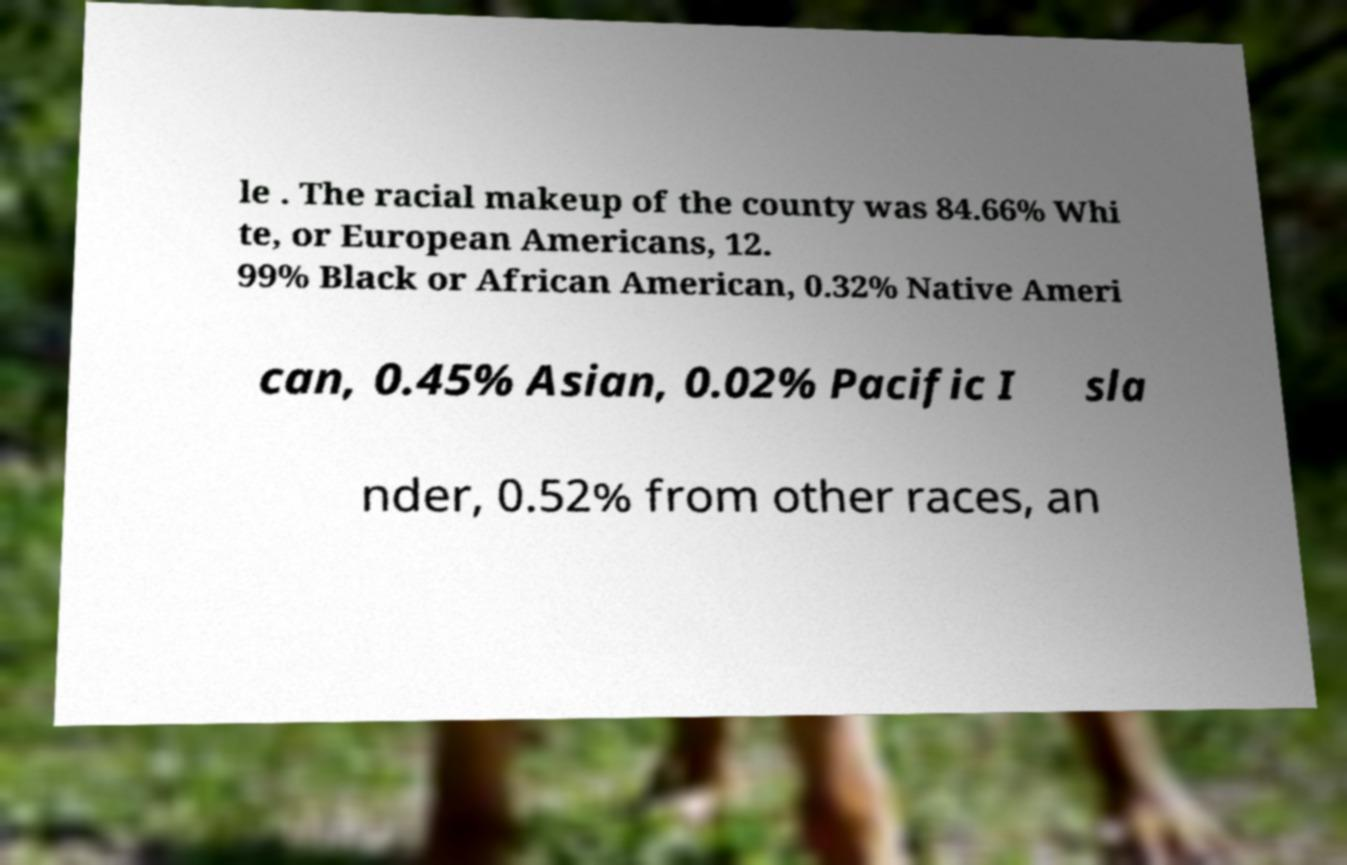Could you extract and type out the text from this image? le . The racial makeup of the county was 84.66% Whi te, or European Americans, 12. 99% Black or African American, 0.32% Native Ameri can, 0.45% Asian, 0.02% Pacific I sla nder, 0.52% from other races, an 